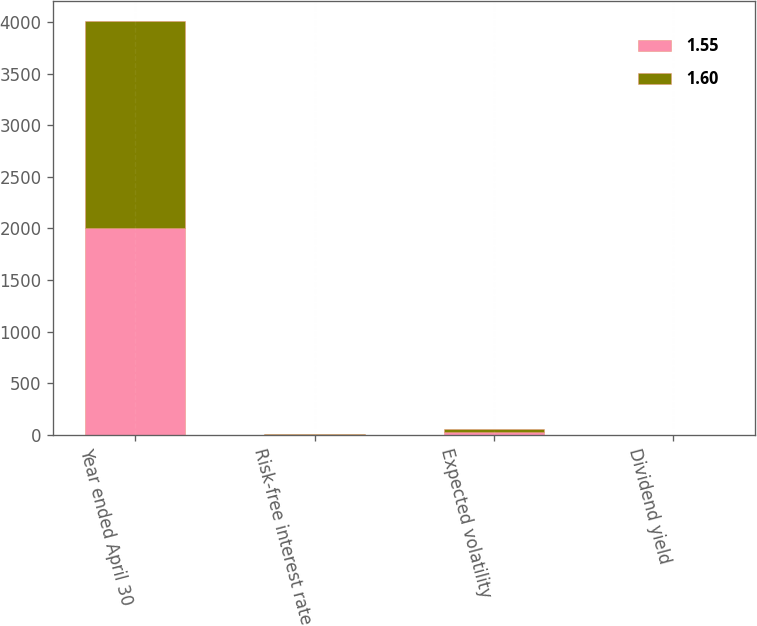Convert chart. <chart><loc_0><loc_0><loc_500><loc_500><stacked_bar_chart><ecel><fcel>Year ended April 30<fcel>Risk-free interest rate<fcel>Expected volatility<fcel>Dividend yield<nl><fcel>1.55<fcel>2004<fcel>1.76<fcel>31.65<fcel>1.65<nl><fcel>1.6<fcel>2003<fcel>3.37<fcel>29.04<fcel>1.5<nl></chart> 